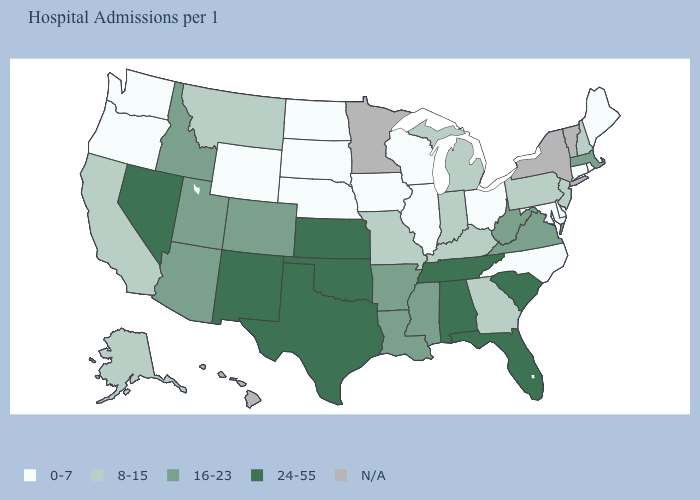Is the legend a continuous bar?
Short answer required. No. What is the value of Maryland?
Short answer required. 0-7. What is the lowest value in the USA?
Be succinct. 0-7. How many symbols are there in the legend?
Answer briefly. 5. Name the states that have a value in the range 0-7?
Concise answer only. Connecticut, Delaware, Illinois, Iowa, Maine, Maryland, Nebraska, North Carolina, North Dakota, Ohio, Oregon, Rhode Island, South Dakota, Washington, Wisconsin, Wyoming. Name the states that have a value in the range 8-15?
Give a very brief answer. Alaska, California, Georgia, Indiana, Kentucky, Michigan, Missouri, Montana, New Hampshire, New Jersey, Pennsylvania. What is the value of Kentucky?
Give a very brief answer. 8-15. Among the states that border Ohio , does Pennsylvania have the lowest value?
Answer briefly. Yes. What is the value of New York?
Give a very brief answer. N/A. What is the value of Iowa?
Keep it brief. 0-7. What is the highest value in the USA?
Short answer required. 24-55. How many symbols are there in the legend?
Keep it brief. 5. 